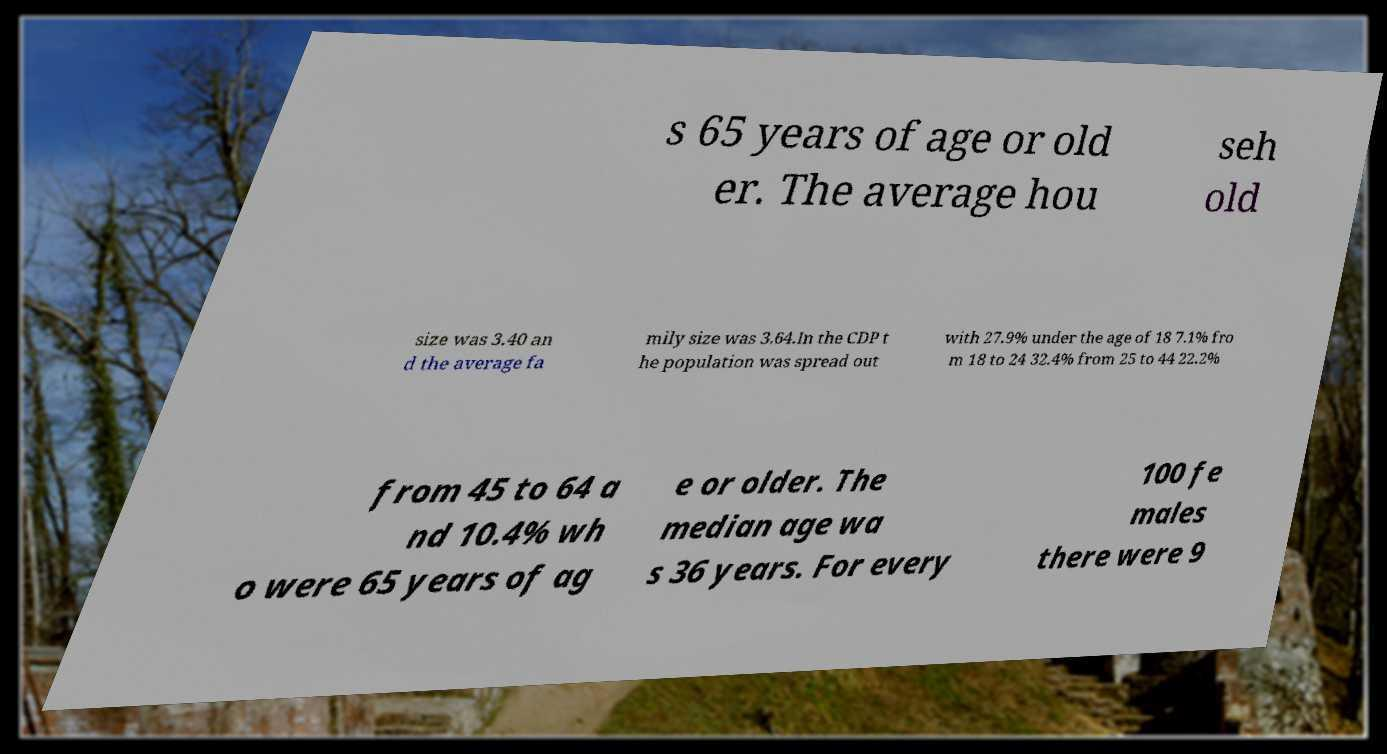For documentation purposes, I need the text within this image transcribed. Could you provide that? s 65 years of age or old er. The average hou seh old size was 3.40 an d the average fa mily size was 3.64.In the CDP t he population was spread out with 27.9% under the age of 18 7.1% fro m 18 to 24 32.4% from 25 to 44 22.2% from 45 to 64 a nd 10.4% wh o were 65 years of ag e or older. The median age wa s 36 years. For every 100 fe males there were 9 